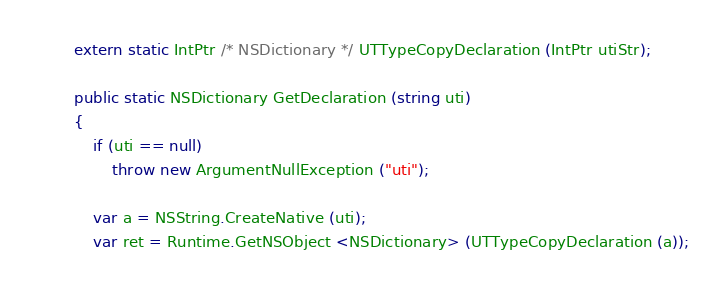<code> <loc_0><loc_0><loc_500><loc_500><_C#_>		extern static IntPtr /* NSDictionary */ UTTypeCopyDeclaration (IntPtr utiStr);

		public static NSDictionary GetDeclaration (string uti)
		{
			if (uti == null)
				throw new ArgumentNullException ("uti");

			var a = NSString.CreateNative (uti);
			var ret = Runtime.GetNSObject <NSDictionary> (UTTypeCopyDeclaration (a));</code> 